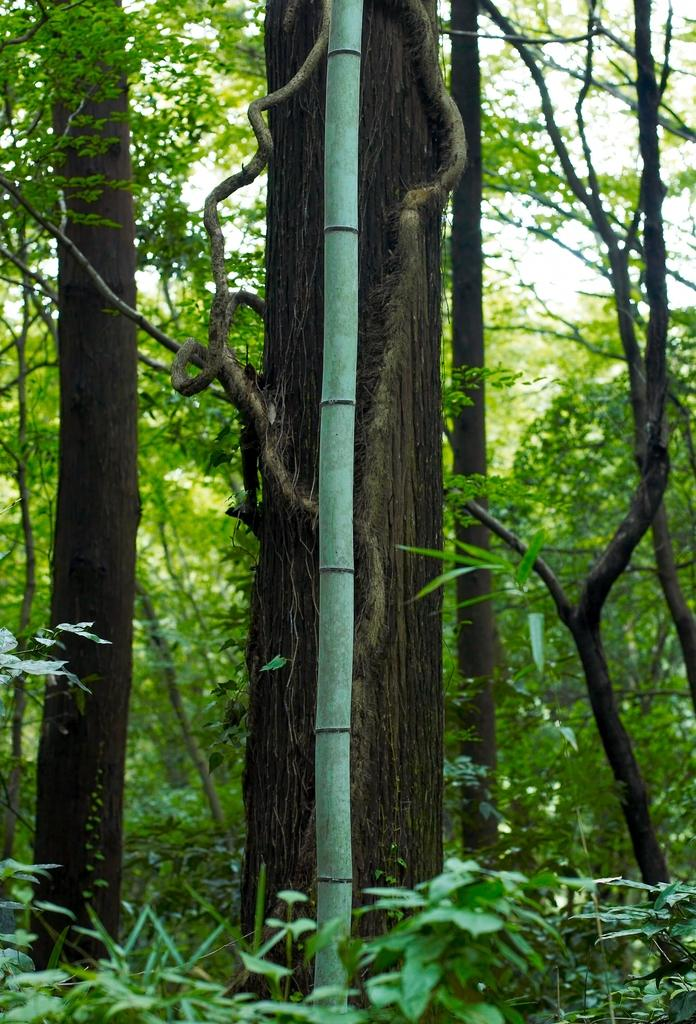What type of vegetation can be seen in the image? There are trees in the image. Where might this image have been taken? The image appears to be taken in a forest. What can be seen at the bottom of the image? There are plants visible at the bottom of the image. What type of house can be seen in the image? There is no house present in the image; it features trees and plants in a forest setting. What type of plough is being used to cultivate the plants in the image? There is no plough present in the image; it is a natural forest setting with no signs of cultivation. 